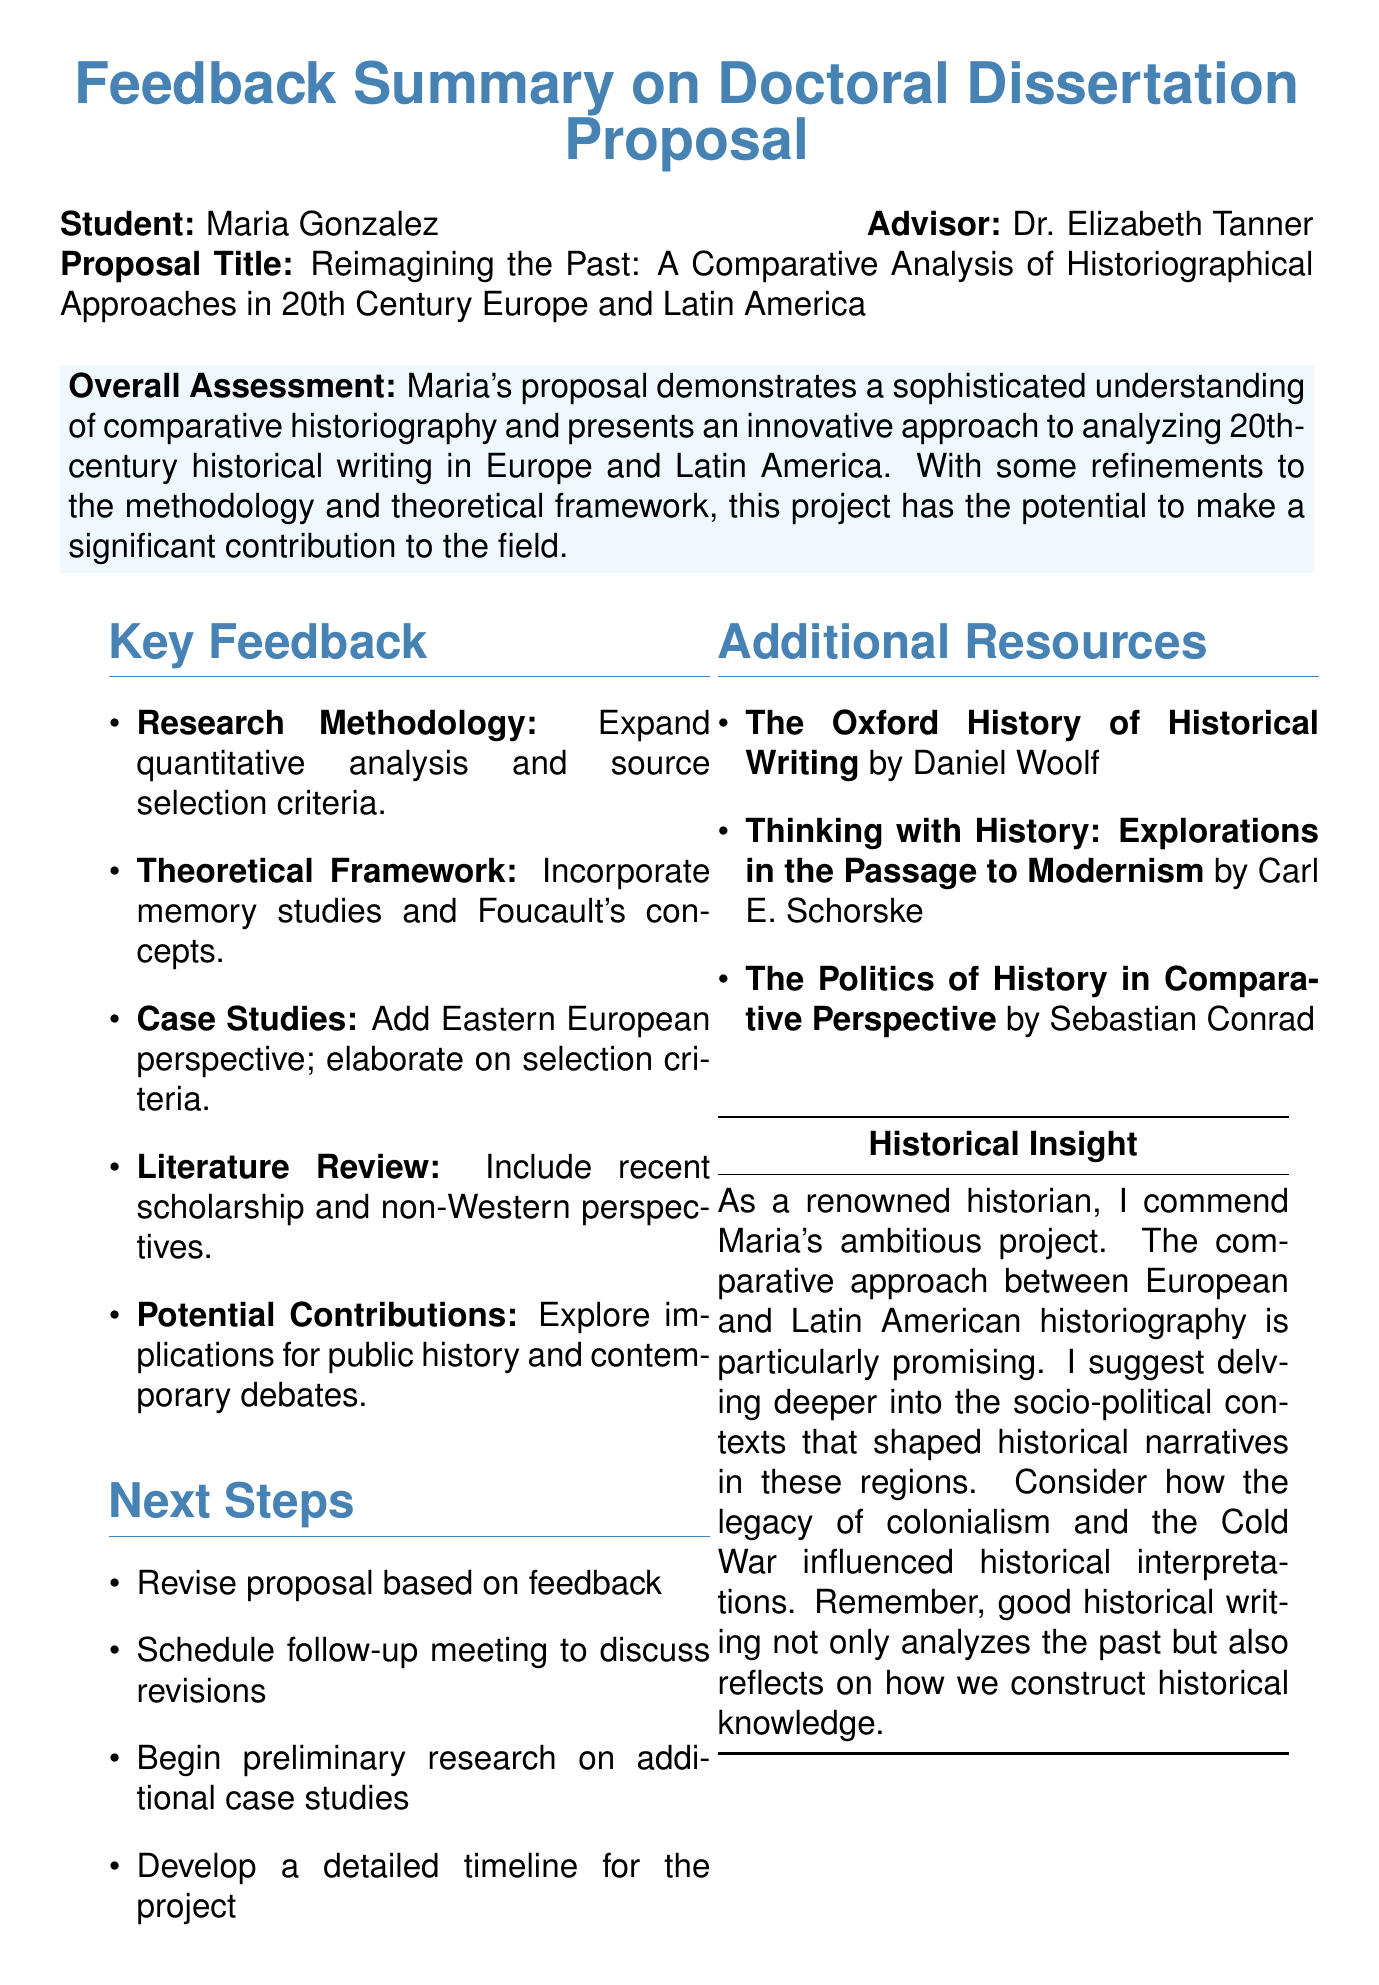what is the name of the student? The student's name is listed at the top of the document.
Answer: Maria Gonzalez who is the advisor for the dissertation proposal? The advisor's name is included in the document after the student's name.
Answer: Dr. Elizabeth Tanner what is the title of the dissertation proposal? The title is prominently stated in the document.
Answer: Reimagining the Past: A Comparative Analysis of Historiographical Approaches in 20th Century Europe and Latin America how many key feedback sections are there? The document lists several feedback sections, and counting them gives the total.
Answer: Five which theory is strongly grounded in the theoretical framework? One specific theory is mentioned in the feedback on the theoretical framework.
Answer: Postcolonial theory what type of case study is suggested for broader perspective? The document specifies a case study type to add for a better analysis.
Answer: Eastern Europe what is one potential contribution mentioned? The document includes potential contributions graduate students should consider for their research.
Answer: Transnational influences on historical writing what is the overall assessment of the proposal? The overall assessment is provided at the top of the feedback section.
Answer: Sophisticated understanding of comparative historiography which resource discusses historiographical developments globally? The resource section contains multiple titles; one addresses historiographical developments.
Answer: The Oxford History of Historical Writing 